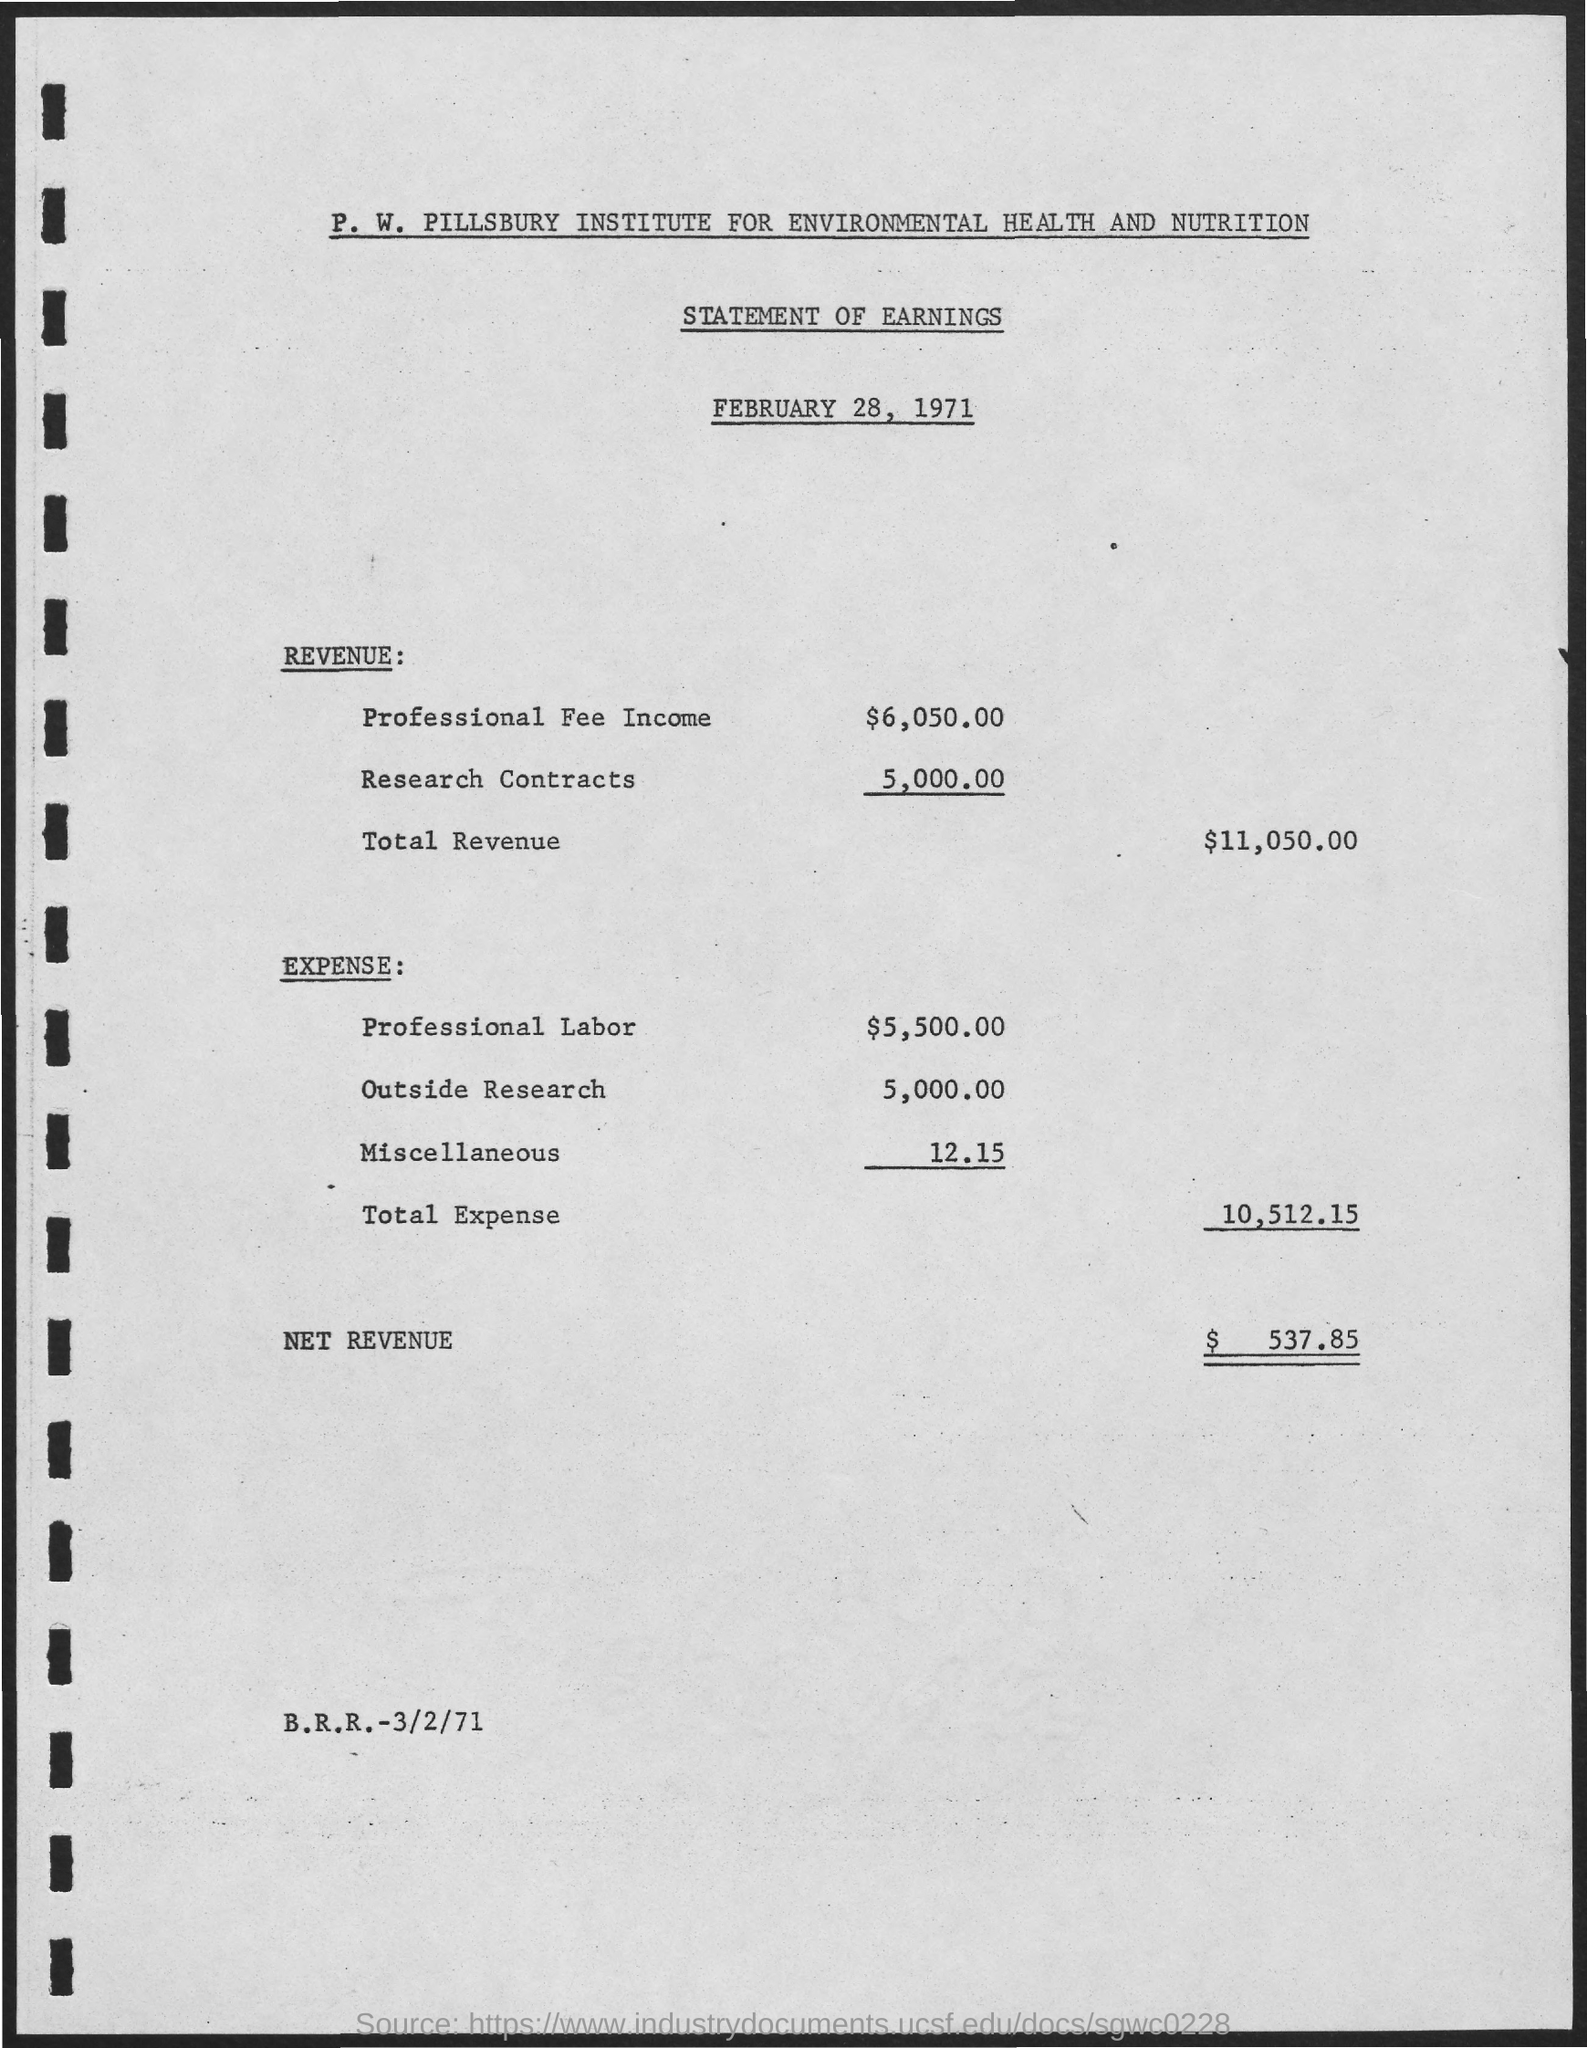Mention a couple of crucial points in this snapshot. The revenue earned from professional fee income was $6,050.00. 